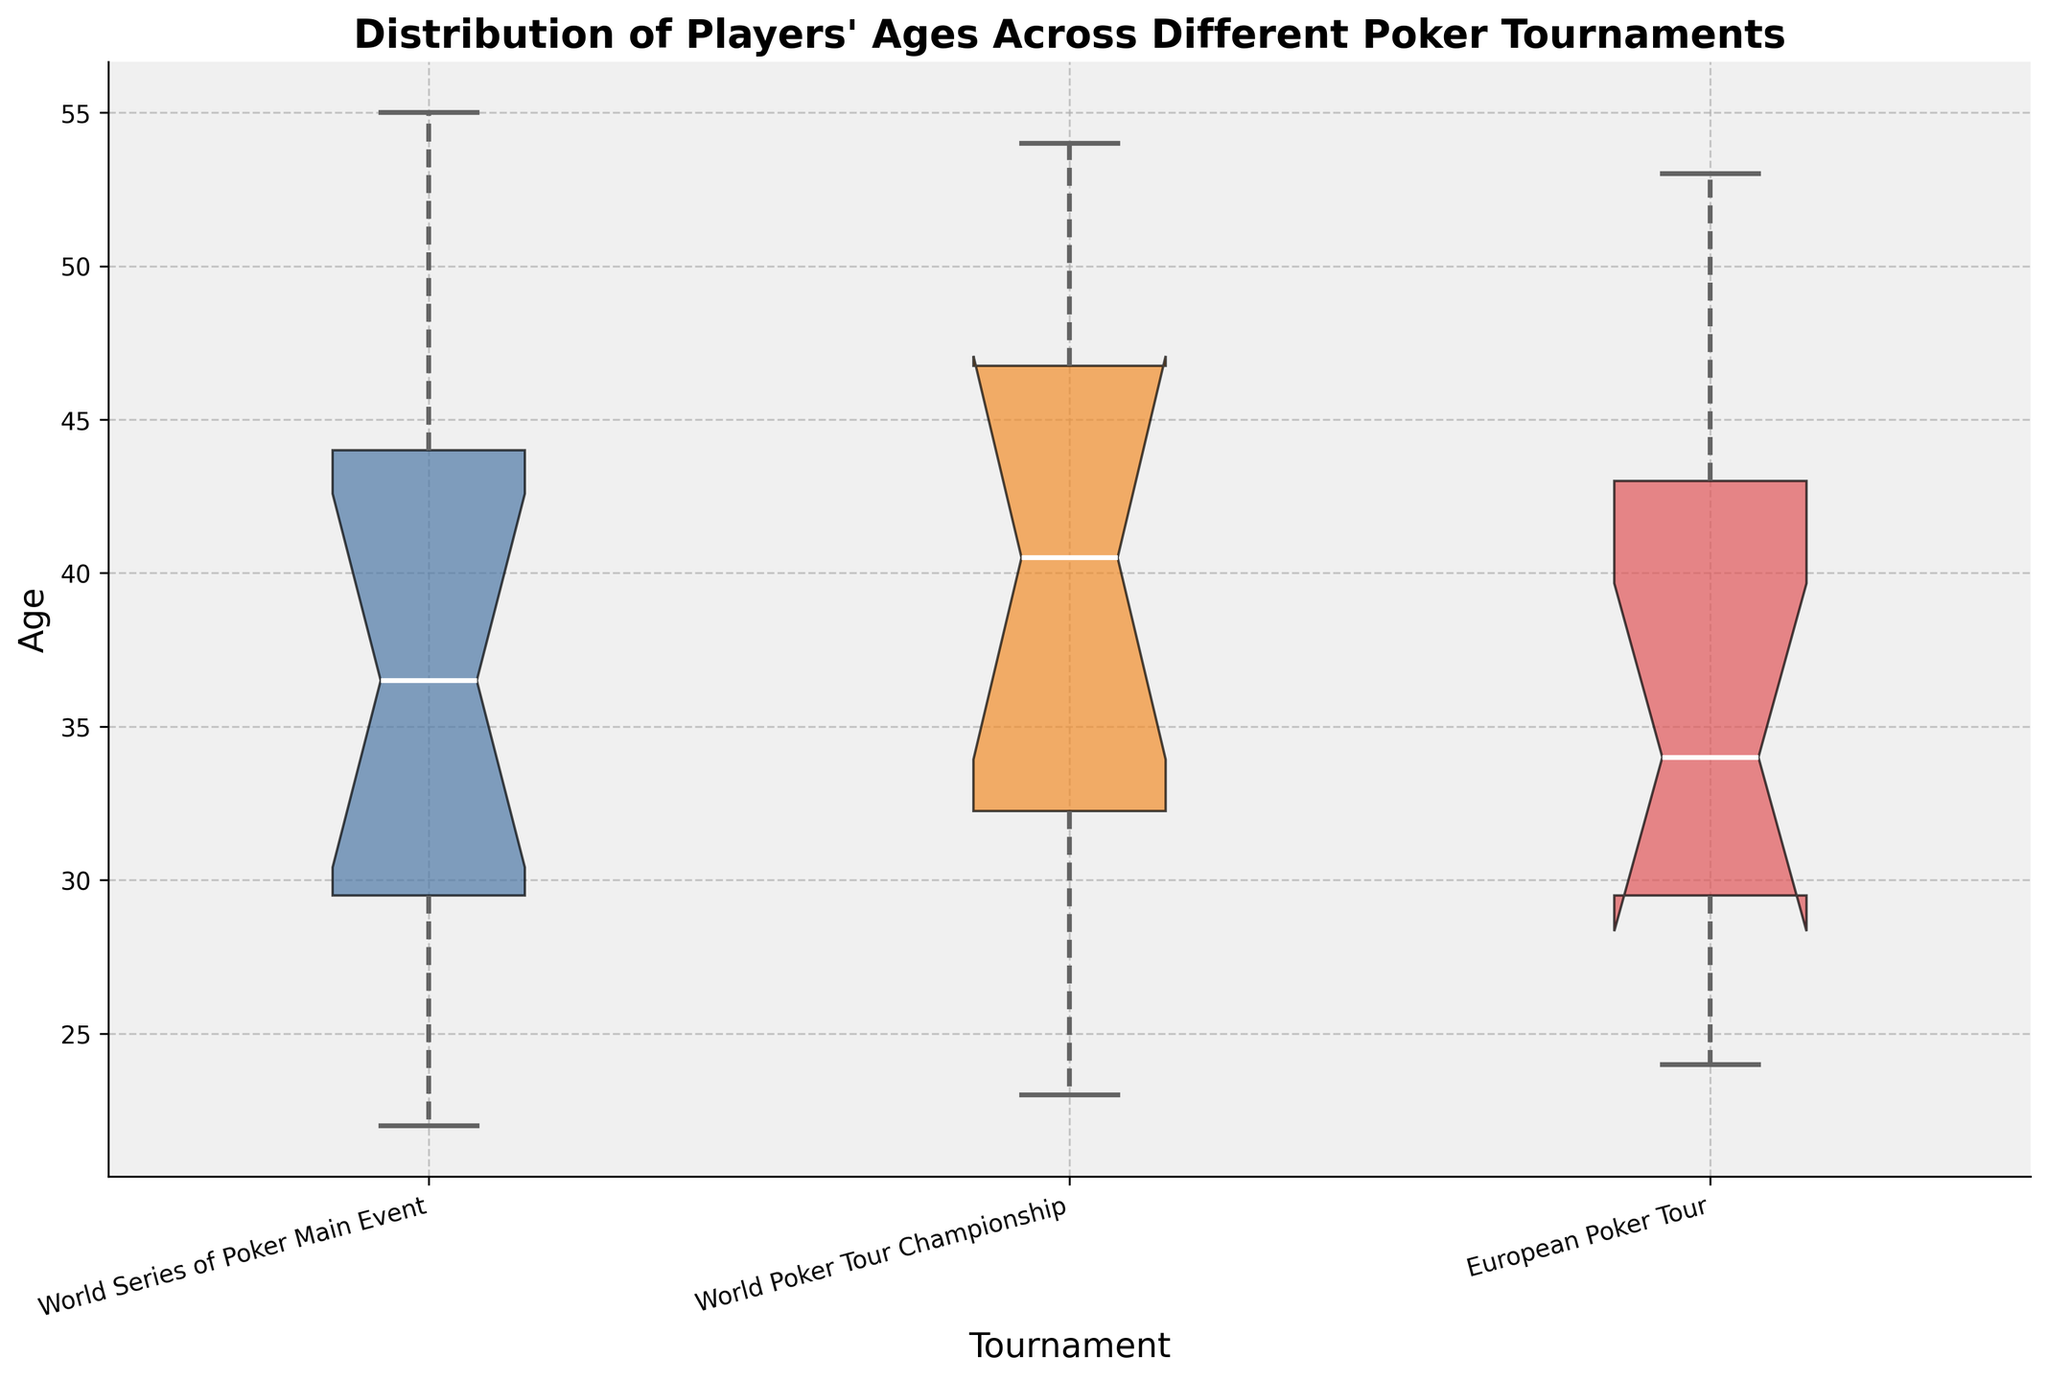What's the title of the plot? The title of the plot is clearly shown at the top of the figure.
Answer: Distribution of Players' Ages Across Different Poker Tournaments What is the range of ages for the World Series of Poker Main Event? The range is found by noting the smallest and largest ages in the 'World Series of Poker Main Event' box plot, represented by the lower and upper whiskers.
Answer: 22 to 55 What tournament has the median age highest among the three? The median age values are marked by the white line inside each box. The highest median line is within the 'European Poker Tour' box.
Answer: European Poker Tour Which tournament shows the largest interquartile range (IQR) for players' ages? The IQR is represented by the length of the colored box (difference between the upper and lower quartiles). The 'World Poker Tour Championship' has the largest box.
Answer: World Poker Tour Championship Are there any outliers in the European Poker Tour data? Outliers are depicted as individual points outside the whiskers on a notched box plot. The European Poker Tour has no such individual points outside the whiskers.
Answer: No Between World Series of Poker Main Event and World Poker Tour Championship, which one has a broader age distribution? Broader age distribution is determined by the total span from the bottom to the top whisker, i.e., the total range. The World Series of Poker Main Event has a broader total span.
Answer: World Series of Poker Main Event Which tournament has the youngest player’s age represented? The youngest player’s age is at the bottom of the whisker, and in this figure, the lowest bottom whisker is for the 'World Series of Poker Main Event'.
Answer: World Series of Poker Main Event What is the difference between the median ages of the World Series of Poker Main Event and the World Poker Tour Championship? To find this difference, identify the white line positions (medians) for both tournaments. Subtract the 'World Series of Poker Main Event' median (34) from the 'World Poker Tour Championship' median (38).
Answer: 4 Is there a significant overlap in median ages between any two tournaments? Significant overlap in median ages can be determined by the notches around the median lines. Here, there is overlap between 'World Series of Poker Main Event' and 'World Poker Tour Championship'.
Answer: Yes 